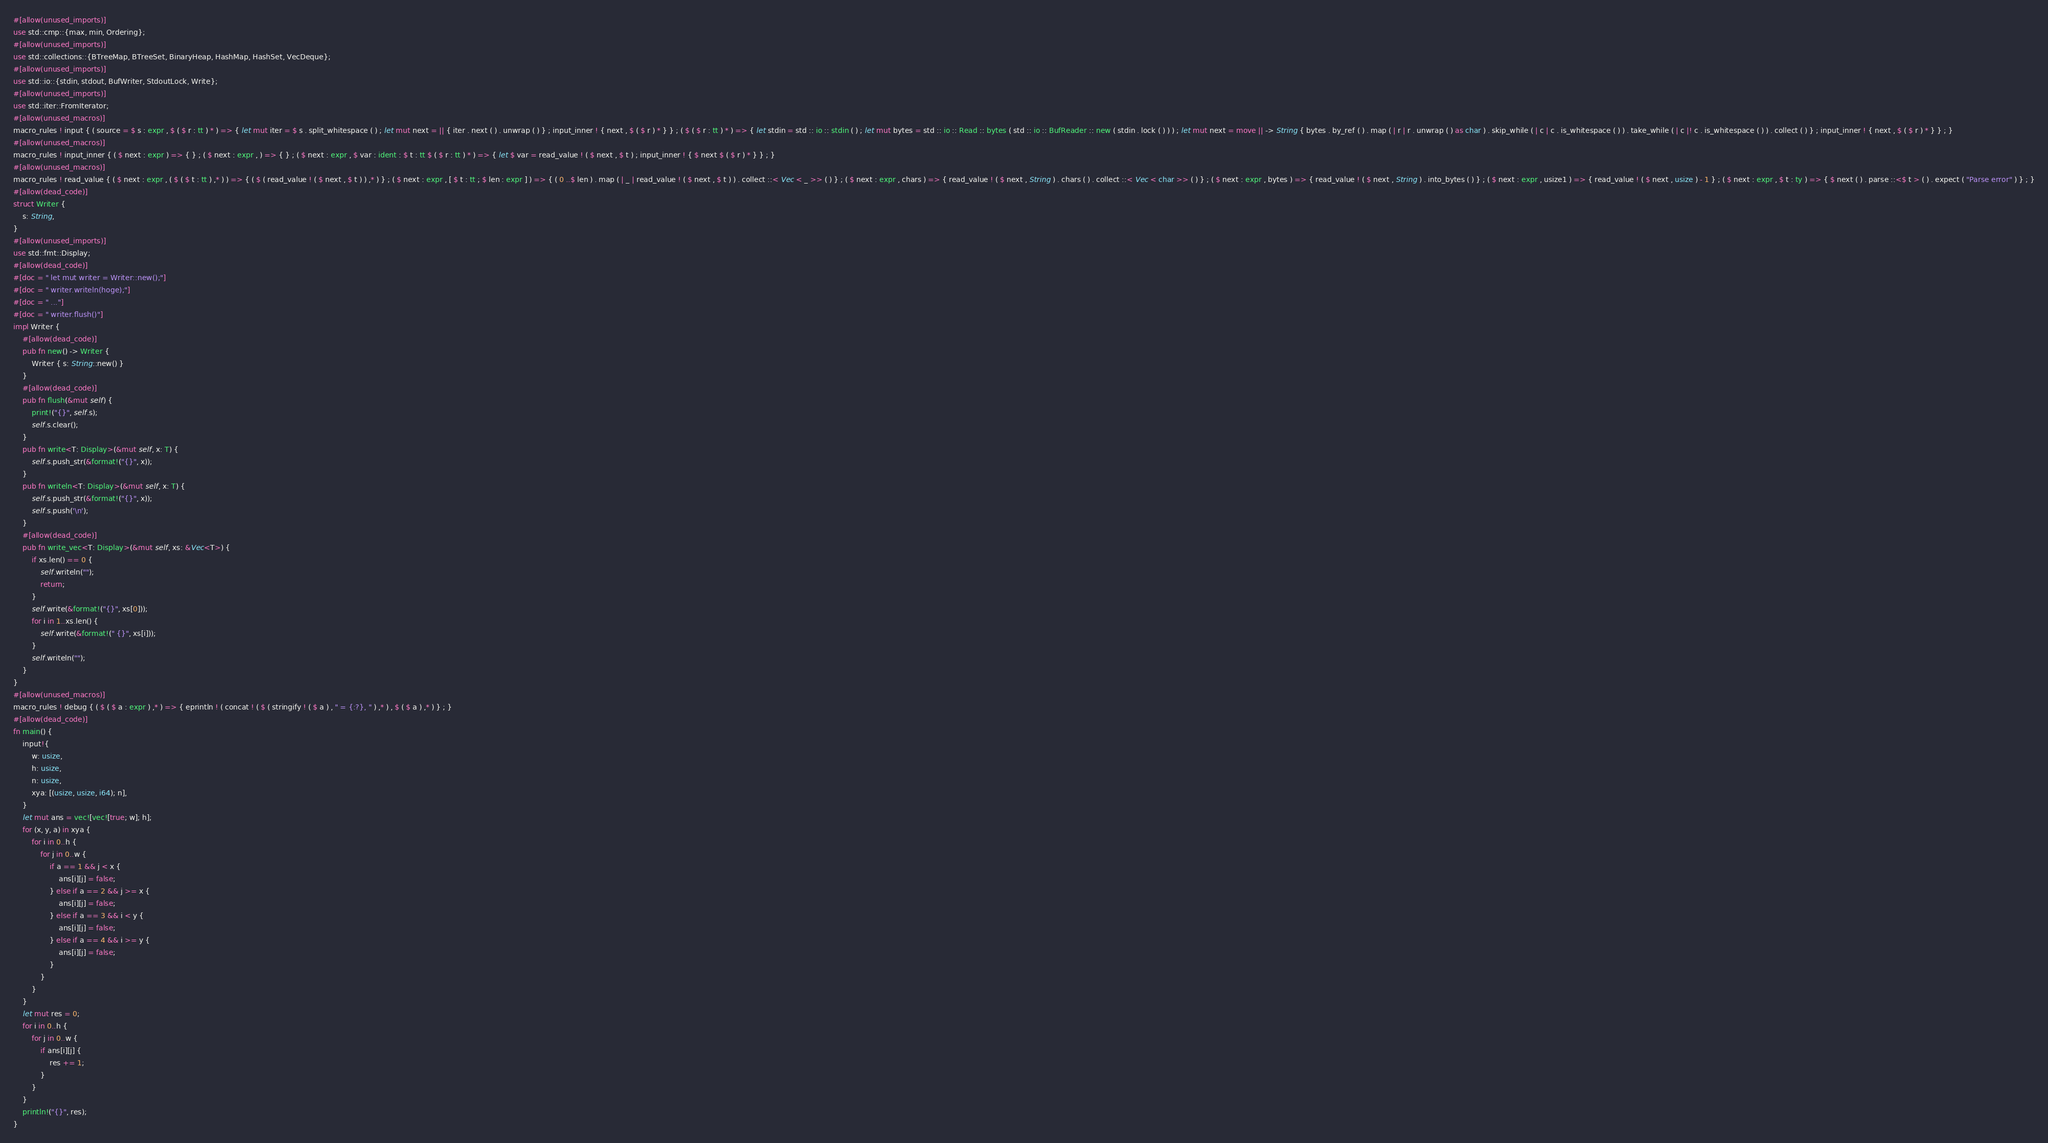<code> <loc_0><loc_0><loc_500><loc_500><_Rust_>#[allow(unused_imports)]
use std::cmp::{max, min, Ordering};
#[allow(unused_imports)]
use std::collections::{BTreeMap, BTreeSet, BinaryHeap, HashMap, HashSet, VecDeque};
#[allow(unused_imports)]
use std::io::{stdin, stdout, BufWriter, StdoutLock, Write};
#[allow(unused_imports)]
use std::iter::FromIterator;
#[allow(unused_macros)]
macro_rules ! input { ( source = $ s : expr , $ ( $ r : tt ) * ) => { let mut iter = $ s . split_whitespace ( ) ; let mut next = || { iter . next ( ) . unwrap ( ) } ; input_inner ! { next , $ ( $ r ) * } } ; ( $ ( $ r : tt ) * ) => { let stdin = std :: io :: stdin ( ) ; let mut bytes = std :: io :: Read :: bytes ( std :: io :: BufReader :: new ( stdin . lock ( ) ) ) ; let mut next = move || -> String { bytes . by_ref ( ) . map ( | r | r . unwrap ( ) as char ) . skip_while ( | c | c . is_whitespace ( ) ) . take_while ( | c |! c . is_whitespace ( ) ) . collect ( ) } ; input_inner ! { next , $ ( $ r ) * } } ; }
#[allow(unused_macros)]
macro_rules ! input_inner { ( $ next : expr ) => { } ; ( $ next : expr , ) => { } ; ( $ next : expr , $ var : ident : $ t : tt $ ( $ r : tt ) * ) => { let $ var = read_value ! ( $ next , $ t ) ; input_inner ! { $ next $ ( $ r ) * } } ; }
#[allow(unused_macros)]
macro_rules ! read_value { ( $ next : expr , ( $ ( $ t : tt ) ,* ) ) => { ( $ ( read_value ! ( $ next , $ t ) ) ,* ) } ; ( $ next : expr , [ $ t : tt ; $ len : expr ] ) => { ( 0 ..$ len ) . map ( | _ | read_value ! ( $ next , $ t ) ) . collect ::< Vec < _ >> ( ) } ; ( $ next : expr , chars ) => { read_value ! ( $ next , String ) . chars ( ) . collect ::< Vec < char >> ( ) } ; ( $ next : expr , bytes ) => { read_value ! ( $ next , String ) . into_bytes ( ) } ; ( $ next : expr , usize1 ) => { read_value ! ( $ next , usize ) - 1 } ; ( $ next : expr , $ t : ty ) => { $ next ( ) . parse ::<$ t > ( ) . expect ( "Parse error" ) } ; }
#[allow(dead_code)]
struct Writer {
    s: String,
}
#[allow(unused_imports)]
use std::fmt::Display;
#[allow(dead_code)]
#[doc = " let mut writer = Writer::new();"]
#[doc = " writer.writeln(hoge);"]
#[doc = " ..."]
#[doc = " writer.flush()"]
impl Writer {
    #[allow(dead_code)]
    pub fn new() -> Writer {
        Writer { s: String::new() }
    }
    #[allow(dead_code)]
    pub fn flush(&mut self) {
        print!("{}", self.s);
        self.s.clear();
    }
    pub fn write<T: Display>(&mut self, x: T) {
        self.s.push_str(&format!("{}", x));
    }
    pub fn writeln<T: Display>(&mut self, x: T) {
        self.s.push_str(&format!("{}", x));
        self.s.push('\n');
    }
    #[allow(dead_code)]
    pub fn write_vec<T: Display>(&mut self, xs: &Vec<T>) {
        if xs.len() == 0 {
            self.writeln("");
            return;
        }
        self.write(&format!("{}", xs[0]));
        for i in 1..xs.len() {
            self.write(&format!(" {}", xs[i]));
        }
        self.writeln("");
    }
}
#[allow(unused_macros)]
macro_rules ! debug { ( $ ( $ a : expr ) ,* ) => { eprintln ! ( concat ! ( $ ( stringify ! ( $ a ) , " = {:?}, " ) ,* ) , $ ( $ a ) ,* ) } ; }
#[allow(dead_code)]
fn main() {
    input!{
        w: usize,
        h: usize,
        n: usize,
        xya: [(usize, usize, i64); n],
    }
    let mut ans = vec![vec![true; w]; h];
    for (x, y, a) in xya {
        for i in 0..h {
            for j in 0..w {
                if a == 1 && j < x {
                    ans[i][j] = false;
                } else if a == 2 && j >= x {
                    ans[i][j] = false;
                } else if a == 3 && i < y {
                    ans[i][j] = false;
                } else if a == 4 && i >= y {
                    ans[i][j] = false;
                }
            }
        }
    }
    let mut res = 0;
    for i in 0..h {
        for j in 0..w {
            if ans[i][j] {
                res += 1;
            }
        }
    }
    println!("{}", res);
}</code> 